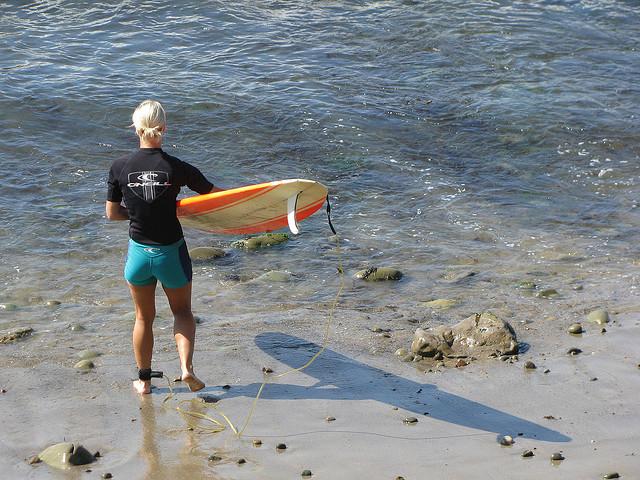Is the water deep?
Quick response, please. No. Is the woman smiling for the camera?
Be succinct. No. What is the man playing with?
Quick response, please. Surfboard. What color are the woman's shorts?
Quick response, please. Blue. 